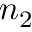<formula> <loc_0><loc_0><loc_500><loc_500>n _ { 2 }</formula> 